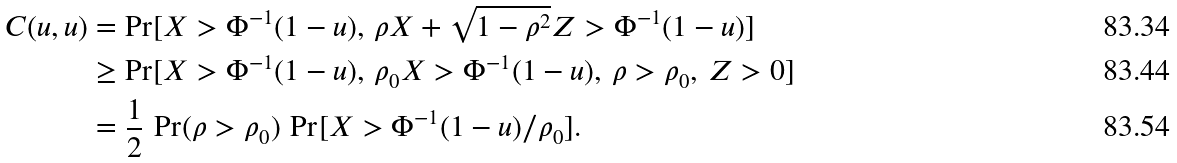<formula> <loc_0><loc_0><loc_500><loc_500>C ( u , u ) & = \Pr [ X > \Phi ^ { - 1 } ( 1 - u ) , \, \rho X + \sqrt { 1 - \rho ^ { 2 } } Z > \Phi ^ { - 1 } ( 1 - u ) ] \\ & \geq \Pr [ X > \Phi ^ { - 1 } ( 1 - u ) , \, \rho _ { 0 } X > \Phi ^ { - 1 } ( 1 - u ) , \, \rho > \rho _ { 0 } , \, Z > 0 ] \\ & = \frac { 1 } { 2 } \, \Pr ( \rho > \rho _ { 0 } ) \, \Pr [ X > \Phi ^ { - 1 } ( 1 - u ) / \rho _ { 0 } ] .</formula> 